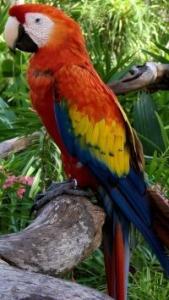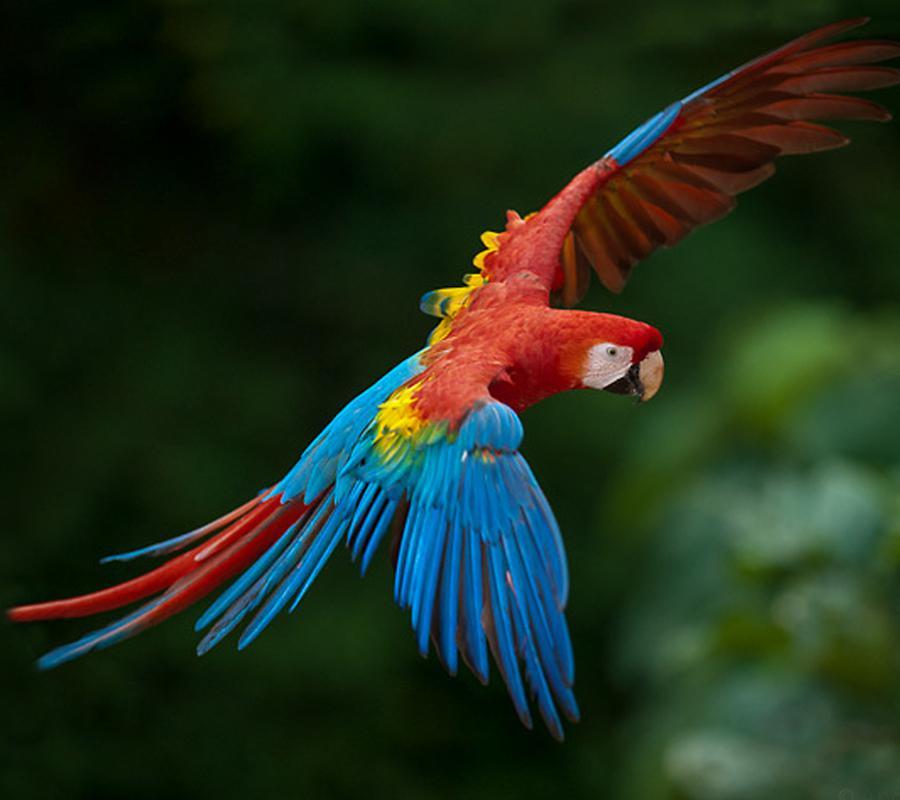The first image is the image on the left, the second image is the image on the right. Considering the images on both sides, is "One of the images shows a red, yellow and blue parrot flying." valid? Answer yes or no. Yes. The first image is the image on the left, the second image is the image on the right. Evaluate the accuracy of this statement regarding the images: "There are a total of three birds.". Is it true? Answer yes or no. No. 